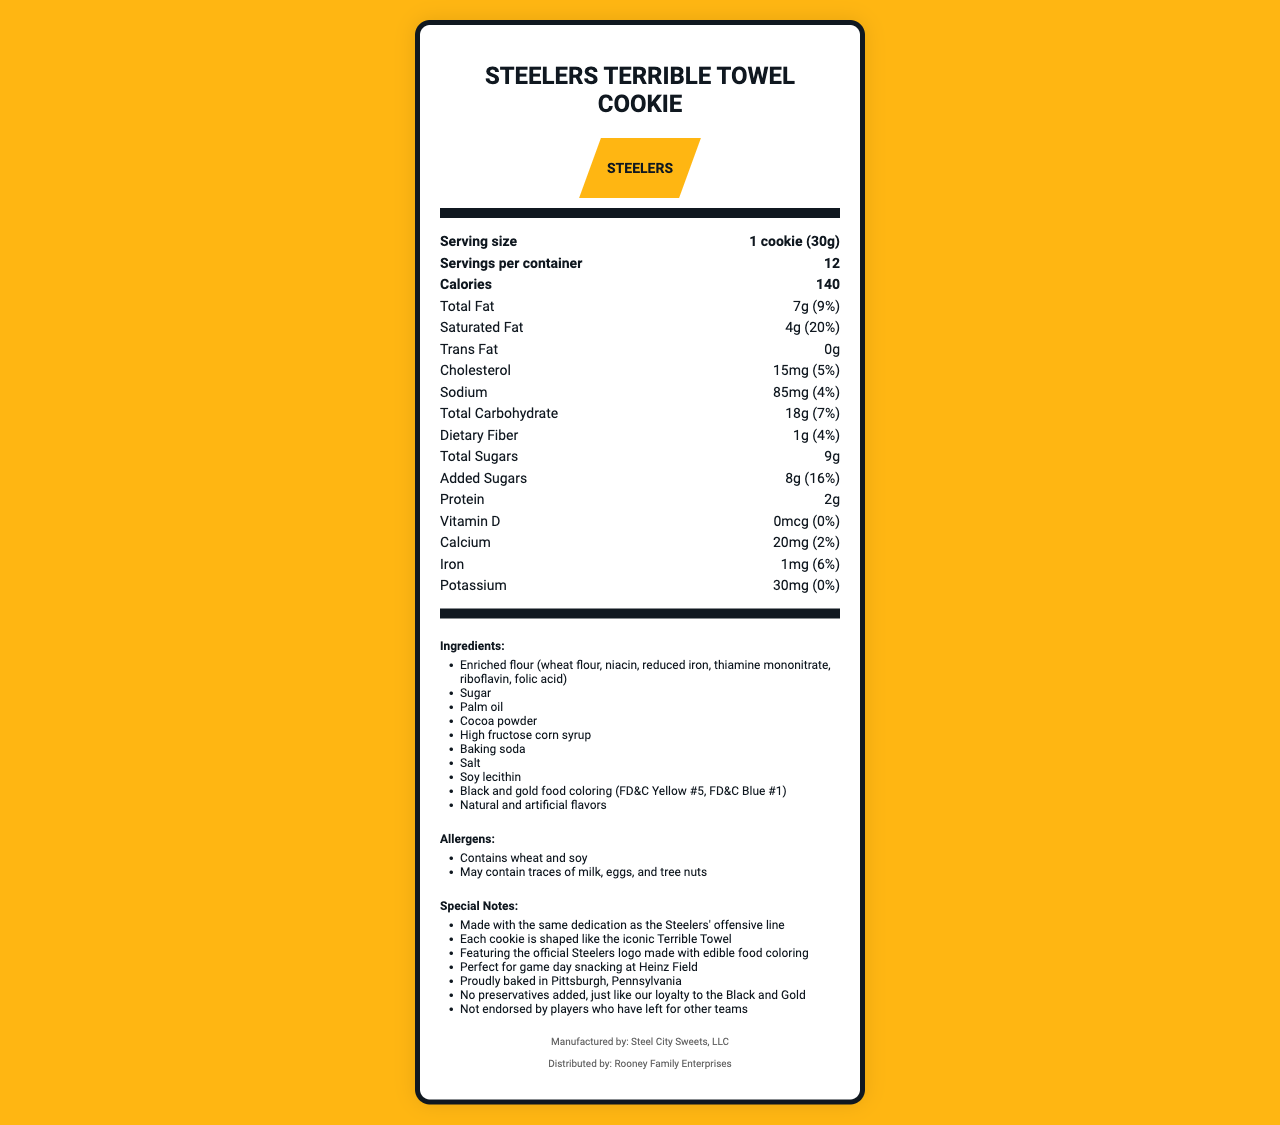what is the serving size of the Terrible Towel cookie? The serving size is clearly mentioned at the beginning of the nutrition facts section as "1 cookie (30g)".
Answer: 1 cookie (30g) how many servings are there per container? The document states "Servings per container" directly below the serving size as 12.
Answer: 12 how many calories does one Terrible Towel cookie contain? The number of calories is listed immediately after the servings per container, and it states the cookie contains 140 calories.
Answer: 140 what percentage of the daily value of saturated fat does one cookie provide? Under the Saturated Fat section, it lists 4g with a daily value percentage of 20%.
Answer: 20% which company manufactures the Terrible Towel cookies? The footer of the document states that the cookies are manufactured by Steel City Sweets, LLC.
Answer: Steel City Sweets, LLC does the product contain any cholesterol? The nutrition facts list the Cholesterol amount as 15mg, indicating the presence of cholesterol.
Answer: Yes what is the total carbohydrate content per serving? The total carbohydrate amount is given as 18g with a daily value of 7% in the nutrition facts section.
Answer: 18g (7% daily value) which of the following ingredients is not listed in the document? A. Sugar B. Cocoa powder C. Skim milk Skim milk is not listed among the ingredients provided.
Answer: C how much dietary fiber does one cookie contain? A. 0.5g B. 1g C. 2g D. 1.5g The dietary fiber content per cookie is listed as 1g.
Answer: B is there any potassium in the cookie? The document states the cookie contains 30mg of potassium.
Answer: Yes how much added sugar is in one cookie? Under the Added Sugars section, it states the amount as 8g with a daily value of 16%.
Answer: 8g summarize the main idea of the document This summary captures the core focus of the document, which is to give a complete nutritional breakdown, ingredients list, allergen information, and special notes about the unique Steelers-themed cookies.
Answer: The document provides detailed nutritional information for Terrible Towel-shaped cookies adorned with Steelers' colors and logo. It includes serving size, calorie content, and percentages of various nutrients. Ingredients, allergens, and special notes emphasizing Steelers fan loyalty and local manufacturing are also highlighted. what are the allergens mentioned in the document? The document specifies these allergens in a dedicated section adjacent to the ingredients list.
Answer: Wheat and soy; may contain traces of milk, eggs, and tree nuts where are the cookies distributed from? The footer of the document mentions that the cookies are distributed by Rooney Family Enterprises.
Answer: Rooney Family Enterprises how much iron does one cookie provide? The iron content is listed as 1mg with a daily value of 6%.
Answer: 1mg (6% daily value) can the document provide information about the effectiveness of the Steelers' offensive line? The document does not contain any data or analysis regarding the performance of the Steelers' offensive line.
Answer: Not enough information 